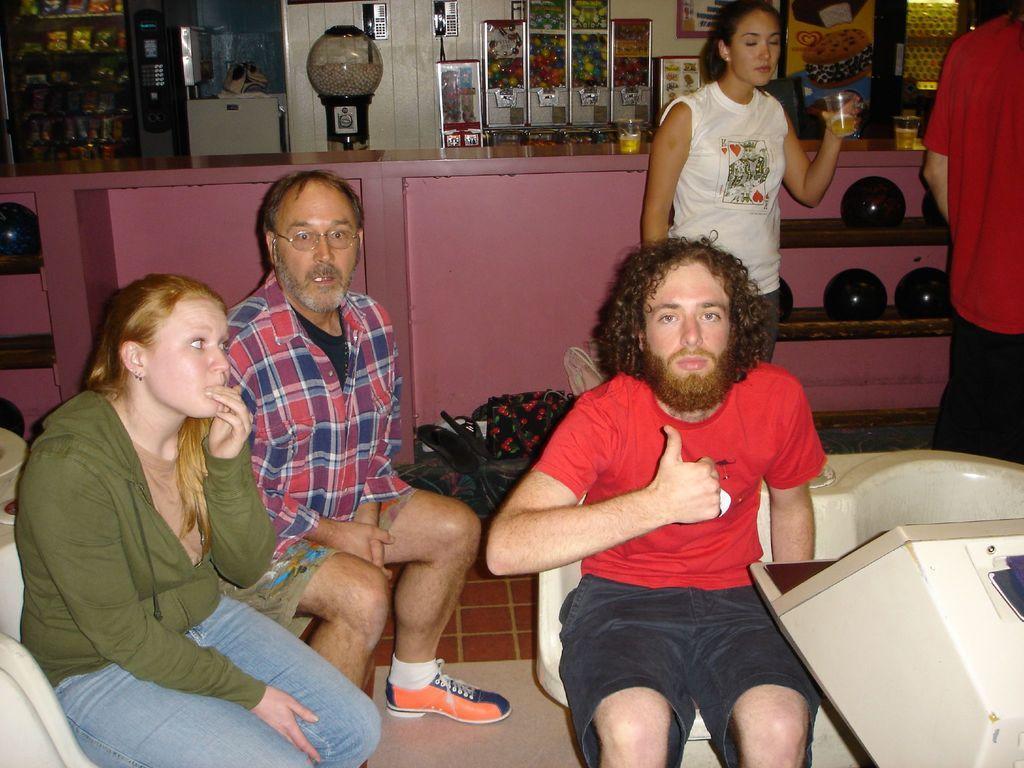In one or two sentences, can you explain what this image depicts? This picture is clicked inside. In the center we can see the three persons sitting on the chairs. On the right there is a white color object and there are some objects placed on the ground. We can see a woman wearing a white color t-shirt, holding a glass and standing on the ground. On the right corner there is a person seems to be standing. In the background we can see the wall, picture frames hanging on the wall and cabinets containing many number of items and a platform on the top of which some items are placed. 